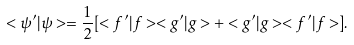Convert formula to latex. <formula><loc_0><loc_0><loc_500><loc_500>< \psi ^ { \prime } | \psi > = \frac { 1 } { 2 } [ < f ^ { \prime } | f > < g ^ { \prime } | g > + < g ^ { \prime } | g > < f ^ { \prime } | f > ] .</formula> 